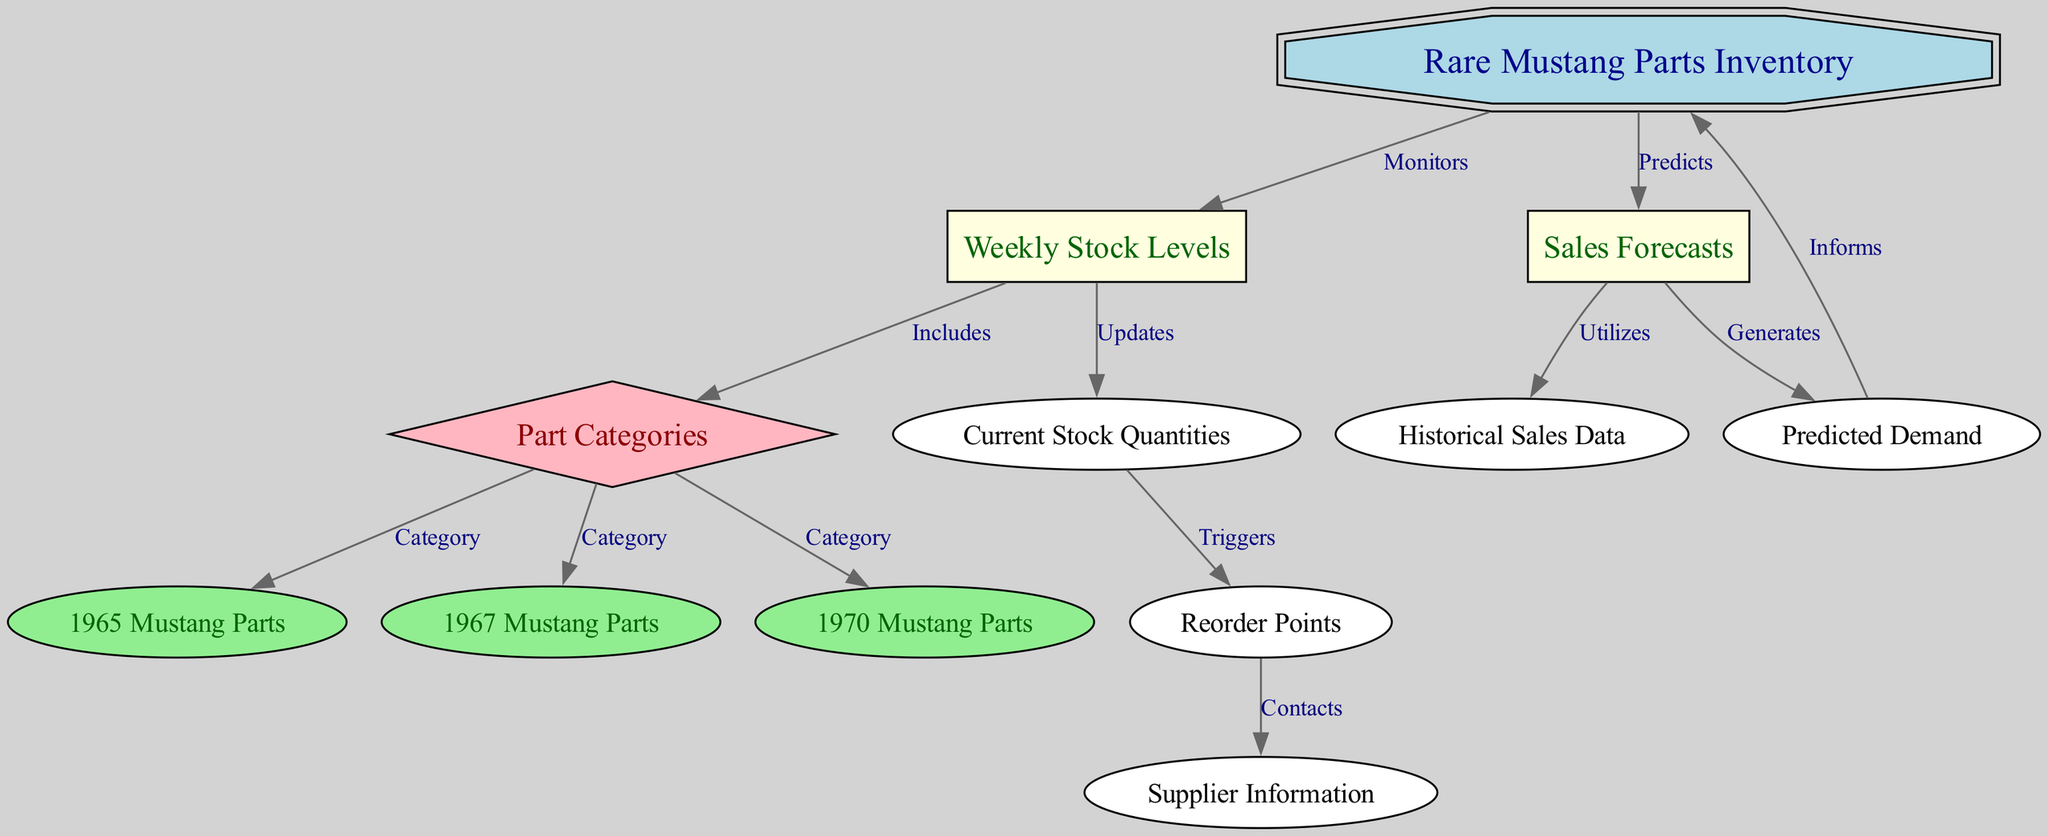What is the central node in the diagram? The central node is the "Rare Mustang Parts Inventory," which is represented as a double octagon and is crucial in the inventory management system. This node connects to multiple other components in the diagram, indicating its importance in the overall process.
Answer: Rare Mustang Parts Inventory How many part categories are included in the inventory? The diagram shows three part categories, which are "1965 Mustang Parts," "1967 Mustang Parts," and "1970 Mustang Parts." These categories are connected from the "Part Categories" node, indicating that they are specific types of rare Mustang parts in the inventory.
Answer: 3 What triggers the reorder points? The "Current Stock Quantities" node triggers the "Reorder Points." According to the diagram, when the stock levels fall below a certain threshold (reorder point), it indicates a need to restock. This connection illustrates how monitoring the current stock informs reorder decisions.
Answer: Current Stock Quantities Which node is utilized to generate predicted demand? The node "Sales Forecasts" is utilized to generate "Predicted Demand." This relationship shows that forecasting potential sales is essential in estimating future stock needs, highlighting the importance of analyzing sales data to predict demand.
Answer: Sales Forecasts What kind of relationships exist between "Weekly Stock Levels" and "Current Stock Quantities"? The relationship is that "Weekly Stock Levels" updates "Current Stock Quantities." This means that the information about weekly stock levels impacts or changes the quantities of parts currently held in inventory, showing the dynamic nature of inventory management.
Answer: Updates How does the "Predicted Demand" inform the inventory management? The "Predicted Demand" informs the "Rare Mustang Parts Inventory." This means that the anticipated demand for parts based on forecasts directly influences decisions made in inventory management, such as restocking or managing stock levels.
Answer: Informs What action is taken when "Reorder Points" are triggered? When "Reorder Points" are triggered, "Supplier Information" is contacted. This indicates a responsive action in the inventory management process, whereby a supplier is notified to replenish stock as soon as it reaches a predefined level.
Answer: Contacts What type of data does "Sales Forecasts" utilize? "Sales Forecasts" utilizes "Historical Sales Data." This emphasizes that projections about future sales are based on past sales trends, indicating the reliance on historical data to make informed forecasts.
Answer: Historical Sales Data 